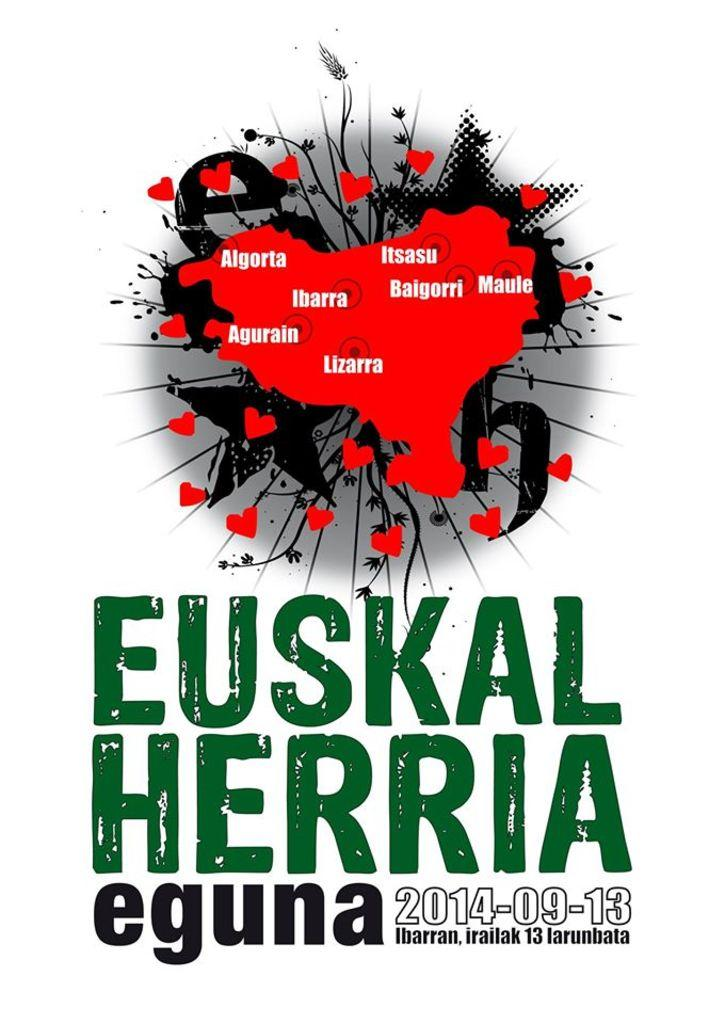<image>
Provide a brief description of the given image. a euskal herria eguna item that has ibarra on it 